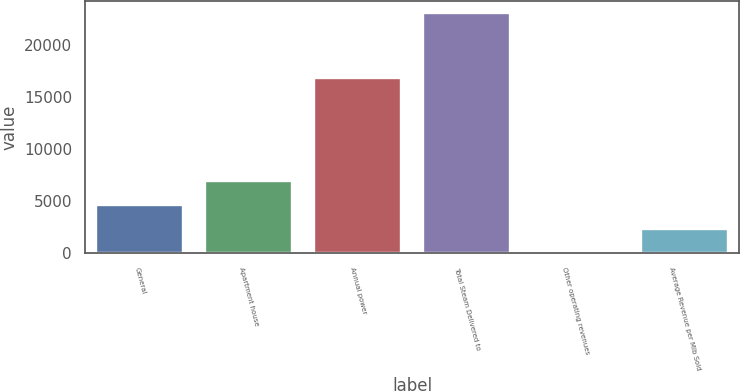Convert chart to OTSL. <chart><loc_0><loc_0><loc_500><loc_500><bar_chart><fcel>General<fcel>Apartment house<fcel>Annual power<fcel>Total Steam Delivered to<fcel>Other operating revenues<fcel>Average Revenue per Mlb Sold<nl><fcel>4618.8<fcel>6920.2<fcel>16767<fcel>23030<fcel>16<fcel>2317.4<nl></chart> 